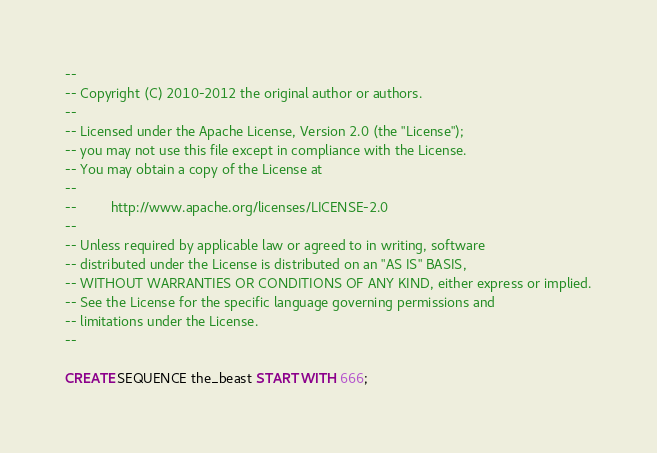Convert code to text. <code><loc_0><loc_0><loc_500><loc_500><_SQL_>--
-- Copyright (C) 2010-2012 the original author or authors.
--
-- Licensed under the Apache License, Version 2.0 (the "License");
-- you may not use this file except in compliance with the License.
-- You may obtain a copy of the License at
--
--         http://www.apache.org/licenses/LICENSE-2.0
--
-- Unless required by applicable law or agreed to in writing, software
-- distributed under the License is distributed on an "AS IS" BASIS,
-- WITHOUT WARRANTIES OR CONDITIONS OF ANY KIND, either express or implied.
-- See the License for the specific language governing permissions and
-- limitations under the License.
--

CREATE SEQUENCE the_beast START WITH 666;</code> 